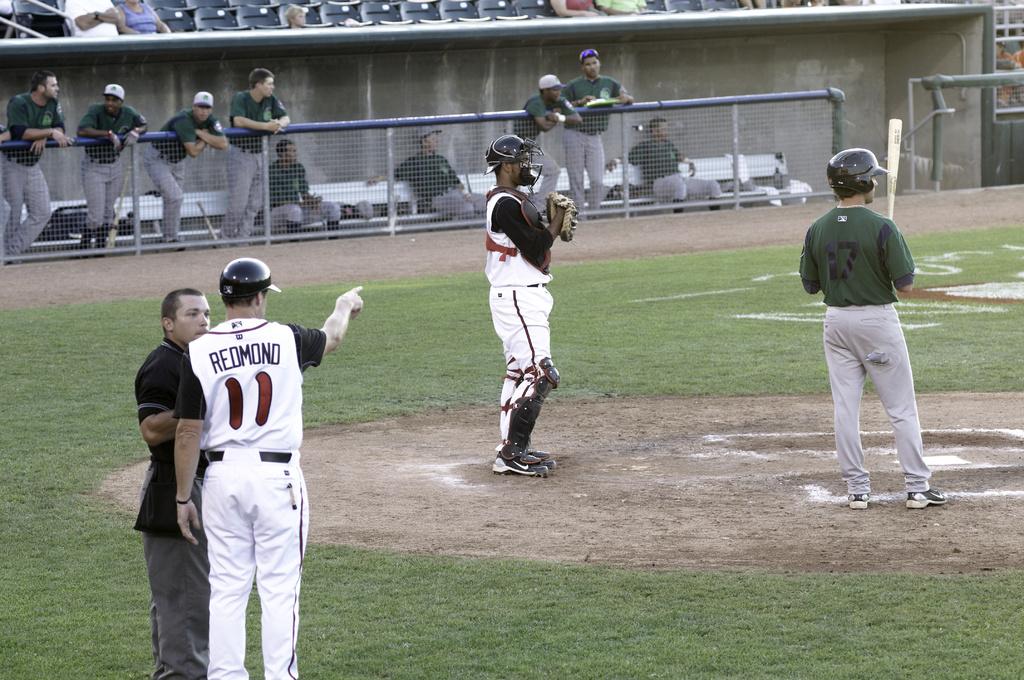What number is redmond?
Give a very brief answer. 11. 